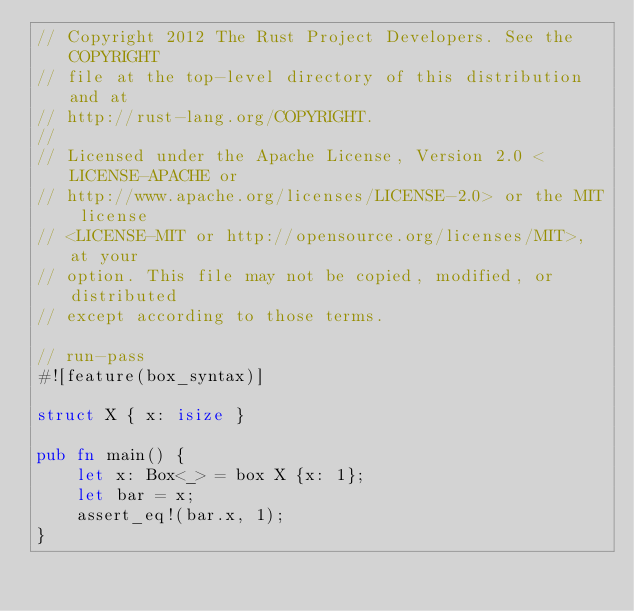Convert code to text. <code><loc_0><loc_0><loc_500><loc_500><_Rust_>// Copyright 2012 The Rust Project Developers. See the COPYRIGHT
// file at the top-level directory of this distribution and at
// http://rust-lang.org/COPYRIGHT.
//
// Licensed under the Apache License, Version 2.0 <LICENSE-APACHE or
// http://www.apache.org/licenses/LICENSE-2.0> or the MIT license
// <LICENSE-MIT or http://opensource.org/licenses/MIT>, at your
// option. This file may not be copied, modified, or distributed
// except according to those terms.

// run-pass
#![feature(box_syntax)]

struct X { x: isize }

pub fn main() {
    let x: Box<_> = box X {x: 1};
    let bar = x;
    assert_eq!(bar.x, 1);
}
</code> 